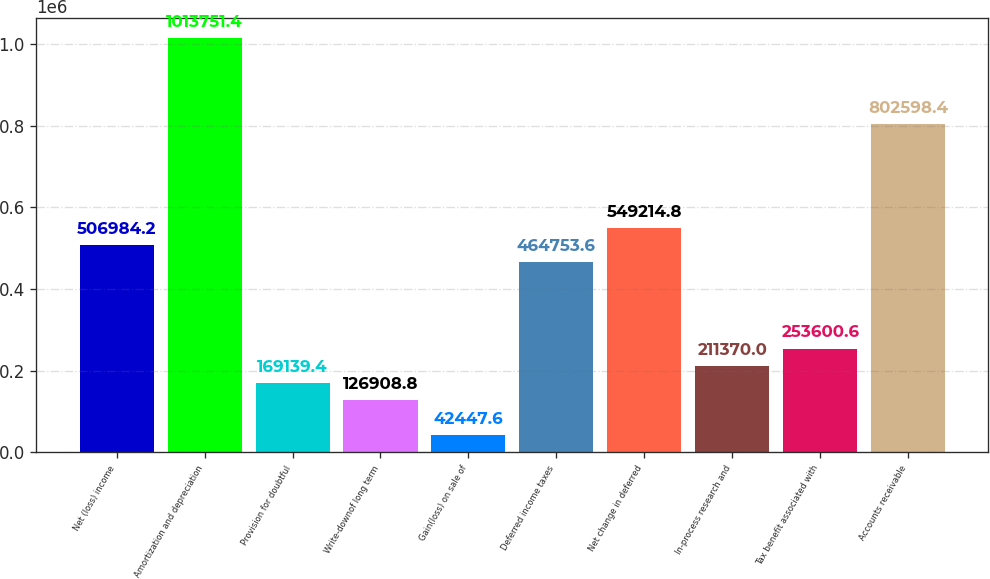Convert chart to OTSL. <chart><loc_0><loc_0><loc_500><loc_500><bar_chart><fcel>Net (loss) income<fcel>Amortization and depreciation<fcel>Provision for doubtful<fcel>Write-downof long term<fcel>Gain(loss) on sale of<fcel>Deferred income taxes<fcel>Net change in deferred<fcel>In-process research and<fcel>Tax benefit associated with<fcel>Accounts receivable<nl><fcel>506984<fcel>1.01375e+06<fcel>169139<fcel>126909<fcel>42447.6<fcel>464754<fcel>549215<fcel>211370<fcel>253601<fcel>802598<nl></chart> 